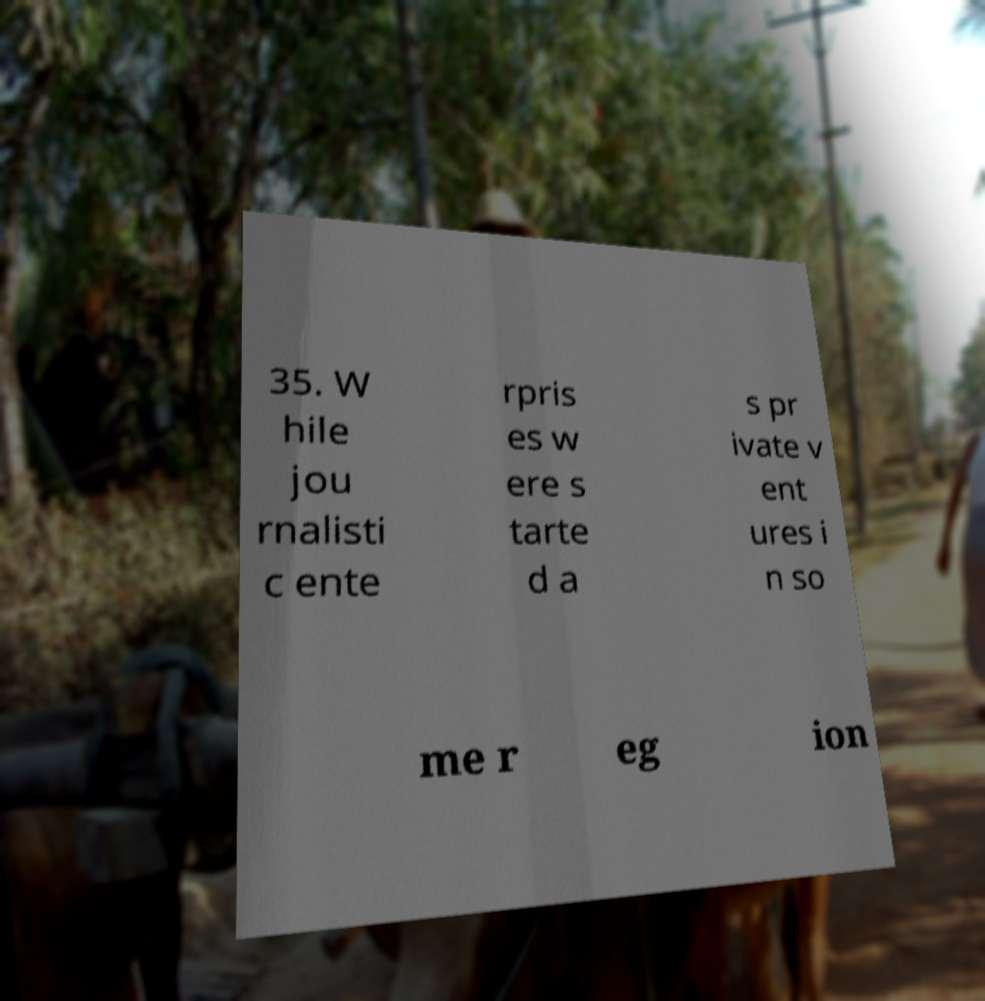Please read and relay the text visible in this image. What does it say? 35. W hile jou rnalisti c ente rpris es w ere s tarte d a s pr ivate v ent ures i n so me r eg ion 